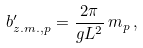Convert formula to latex. <formula><loc_0><loc_0><loc_500><loc_500>b ^ { \prime } _ { z . m . , p } = \frac { 2 \pi } { g L ^ { 2 } } \, m _ { p } \, ,</formula> 